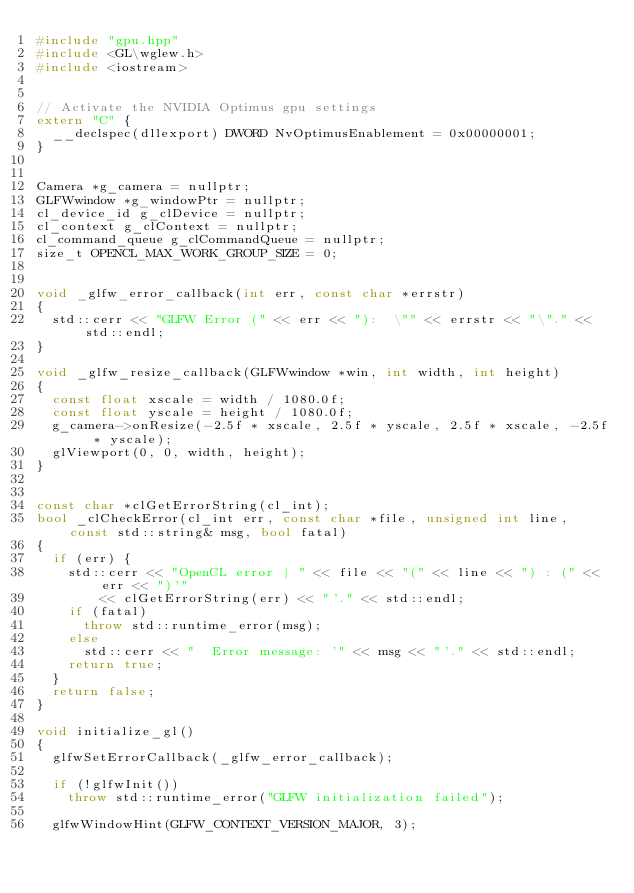Convert code to text. <code><loc_0><loc_0><loc_500><loc_500><_C++_>#include "gpu.hpp"
#include <GL\wglew.h>
#include <iostream>


// Activate the NVIDIA Optimus gpu settings
extern "C" {
	__declspec(dllexport) DWORD NvOptimusEnablement = 0x00000001;
}


Camera *g_camera = nullptr;
GLFWwindow *g_windowPtr = nullptr;
cl_device_id g_clDevice = nullptr;
cl_context g_clContext = nullptr;
cl_command_queue g_clCommandQueue = nullptr;
size_t OPENCL_MAX_WORK_GROUP_SIZE = 0;


void _glfw_error_callback(int err, const char *errstr)
{
	std::cerr << "GLFW Error (" << err << "):  \"" << errstr << "\"." << std::endl;
}

void _glfw_resize_callback(GLFWwindow *win, int width, int height)
{
	const float xscale = width / 1080.0f;
	const float yscale = height / 1080.0f;
	g_camera->onResize(-2.5f * xscale, 2.5f * yscale, 2.5f * xscale, -2.5f * yscale);
	glViewport(0, 0, width, height);
}


const char *clGetErrorString(cl_int);
bool _clCheckError(cl_int err, const char *file, unsigned int line, const std::string& msg, bool fatal)
{
	if (err) {
		std::cerr << "OpenCL error | " << file << "(" << line << ") : (" << err << ")'" 
				<< clGetErrorString(err) << "'." << std::endl;
		if (fatal)
			throw std::runtime_error(msg);
		else
			std::cerr << "  Error message: '" << msg << "'." << std::endl;
		return true;
	}
	return false;
}

void initialize_gl()
{
	glfwSetErrorCallback(_glfw_error_callback);

	if (!glfwInit())
		throw std::runtime_error("GLFW initialization failed");

	glfwWindowHint(GLFW_CONTEXT_VERSION_MAJOR, 3);</code> 